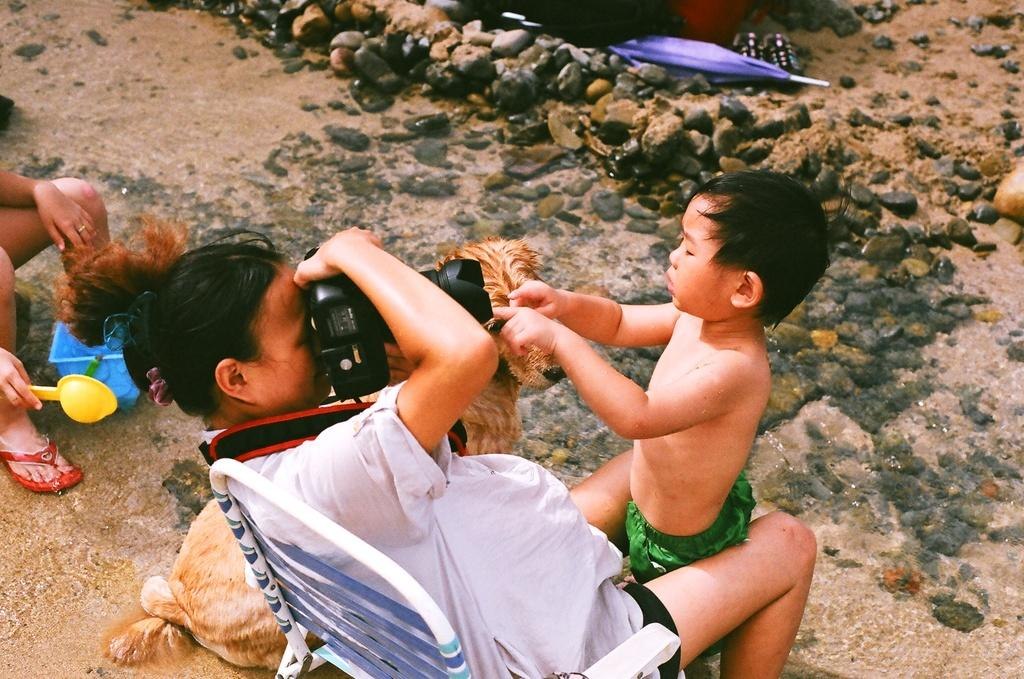Who is the main subject in the image? There is a woman in the image. What is the woman wearing? The woman is wearing a white dress. What is the woman doing in the image? The woman is sitting in a chair and holding a camera in her hands. Who is in front of the woman? There is a kid in front of the woman. What animal is beside the woman? There is a dog beside the woman. What type of roof can be seen in the image? There is no roof visible in the image. What is the woman's reaction to the sink in the image? There is no sink present in the image, so the woman's reaction cannot be determined. 